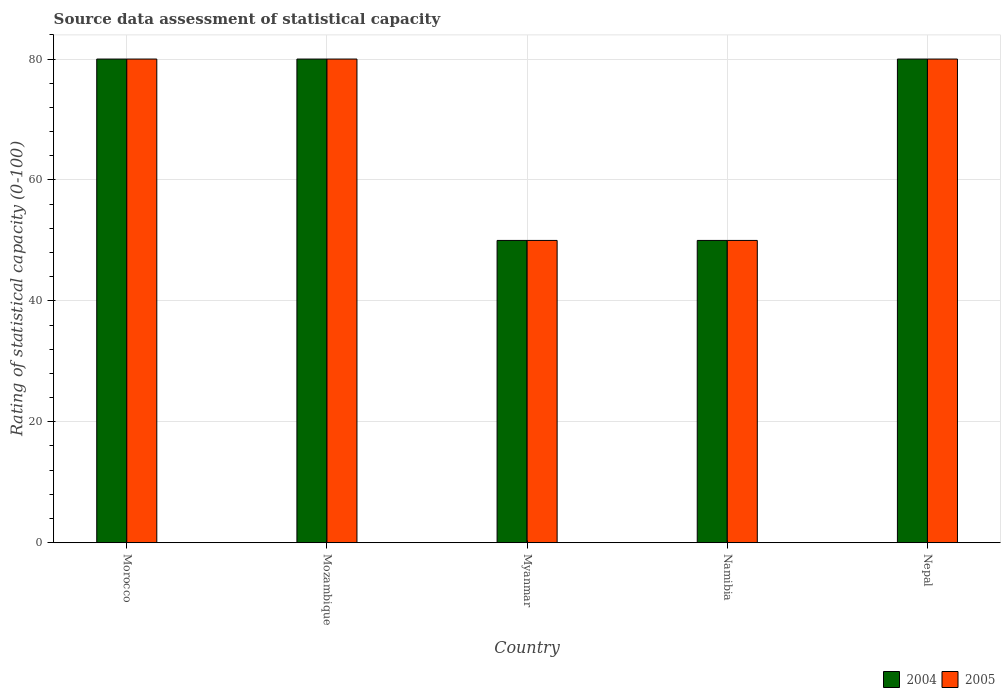How many different coloured bars are there?
Make the answer very short. 2. Are the number of bars per tick equal to the number of legend labels?
Provide a short and direct response. Yes. Are the number of bars on each tick of the X-axis equal?
Offer a terse response. Yes. How many bars are there on the 3rd tick from the left?
Ensure brevity in your answer.  2. What is the label of the 3rd group of bars from the left?
Ensure brevity in your answer.  Myanmar. What is the rating of statistical capacity in 2004 in Myanmar?
Your answer should be very brief. 50. Across all countries, what is the minimum rating of statistical capacity in 2005?
Your answer should be very brief. 50. In which country was the rating of statistical capacity in 2005 maximum?
Your response must be concise. Morocco. In which country was the rating of statistical capacity in 2004 minimum?
Your answer should be compact. Myanmar. What is the total rating of statistical capacity in 2005 in the graph?
Provide a short and direct response. 340. What is the difference between the rating of statistical capacity in 2004 in Morocco and that in Myanmar?
Provide a short and direct response. 30. What is the difference between the rating of statistical capacity in 2005 in Morocco and the rating of statistical capacity in 2004 in Nepal?
Make the answer very short. 0. What is the difference between the rating of statistical capacity of/in 2004 and rating of statistical capacity of/in 2005 in Mozambique?
Offer a very short reply. 0. Is the sum of the rating of statistical capacity in 2004 in Myanmar and Nepal greater than the maximum rating of statistical capacity in 2005 across all countries?
Provide a succinct answer. Yes. What does the 1st bar from the left in Namibia represents?
Offer a very short reply. 2004. How many countries are there in the graph?
Give a very brief answer. 5. Are the values on the major ticks of Y-axis written in scientific E-notation?
Offer a very short reply. No. Does the graph contain any zero values?
Your response must be concise. No. Does the graph contain grids?
Give a very brief answer. Yes. Where does the legend appear in the graph?
Keep it short and to the point. Bottom right. How many legend labels are there?
Provide a succinct answer. 2. How are the legend labels stacked?
Give a very brief answer. Horizontal. What is the title of the graph?
Your answer should be very brief. Source data assessment of statistical capacity. Does "1960" appear as one of the legend labels in the graph?
Make the answer very short. No. What is the label or title of the Y-axis?
Your answer should be compact. Rating of statistical capacity (0-100). What is the Rating of statistical capacity (0-100) of 2004 in Morocco?
Your answer should be compact. 80. What is the Rating of statistical capacity (0-100) in 2005 in Morocco?
Keep it short and to the point. 80. What is the Rating of statistical capacity (0-100) in 2005 in Mozambique?
Give a very brief answer. 80. What is the Rating of statistical capacity (0-100) in 2004 in Myanmar?
Offer a very short reply. 50. What is the Rating of statistical capacity (0-100) of 2005 in Myanmar?
Ensure brevity in your answer.  50. What is the Rating of statistical capacity (0-100) of 2004 in Namibia?
Provide a succinct answer. 50. What is the Rating of statistical capacity (0-100) of 2005 in Namibia?
Your answer should be very brief. 50. Across all countries, what is the maximum Rating of statistical capacity (0-100) of 2005?
Ensure brevity in your answer.  80. What is the total Rating of statistical capacity (0-100) of 2004 in the graph?
Your answer should be compact. 340. What is the total Rating of statistical capacity (0-100) in 2005 in the graph?
Provide a succinct answer. 340. What is the difference between the Rating of statistical capacity (0-100) in 2004 in Morocco and that in Mozambique?
Make the answer very short. 0. What is the difference between the Rating of statistical capacity (0-100) of 2004 in Morocco and that in Myanmar?
Offer a terse response. 30. What is the difference between the Rating of statistical capacity (0-100) in 2005 in Morocco and that in Nepal?
Your response must be concise. 0. What is the difference between the Rating of statistical capacity (0-100) of 2004 in Mozambique and that in Myanmar?
Provide a succinct answer. 30. What is the difference between the Rating of statistical capacity (0-100) in 2004 in Mozambique and that in Nepal?
Give a very brief answer. 0. What is the difference between the Rating of statistical capacity (0-100) of 2005 in Myanmar and that in Nepal?
Your answer should be compact. -30. What is the difference between the Rating of statistical capacity (0-100) in 2004 in Namibia and that in Nepal?
Provide a short and direct response. -30. What is the difference between the Rating of statistical capacity (0-100) in 2005 in Namibia and that in Nepal?
Your answer should be compact. -30. What is the difference between the Rating of statistical capacity (0-100) of 2004 in Morocco and the Rating of statistical capacity (0-100) of 2005 in Mozambique?
Offer a terse response. 0. What is the difference between the Rating of statistical capacity (0-100) in 2004 in Morocco and the Rating of statistical capacity (0-100) in 2005 in Namibia?
Provide a succinct answer. 30. What is the difference between the Rating of statistical capacity (0-100) of 2004 in Morocco and the Rating of statistical capacity (0-100) of 2005 in Nepal?
Offer a terse response. 0. What is the difference between the Rating of statistical capacity (0-100) in 2004 in Mozambique and the Rating of statistical capacity (0-100) in 2005 in Namibia?
Your answer should be compact. 30. What is the difference between the Rating of statistical capacity (0-100) in 2004 in Myanmar and the Rating of statistical capacity (0-100) in 2005 in Namibia?
Provide a succinct answer. 0. What is the average Rating of statistical capacity (0-100) of 2004 per country?
Your answer should be very brief. 68. What is the difference between the Rating of statistical capacity (0-100) in 2004 and Rating of statistical capacity (0-100) in 2005 in Morocco?
Offer a very short reply. 0. What is the difference between the Rating of statistical capacity (0-100) in 2004 and Rating of statistical capacity (0-100) in 2005 in Mozambique?
Offer a terse response. 0. What is the difference between the Rating of statistical capacity (0-100) in 2004 and Rating of statistical capacity (0-100) in 2005 in Myanmar?
Offer a very short reply. 0. What is the difference between the Rating of statistical capacity (0-100) of 2004 and Rating of statistical capacity (0-100) of 2005 in Namibia?
Provide a succinct answer. 0. What is the ratio of the Rating of statistical capacity (0-100) in 2004 in Morocco to that in Mozambique?
Provide a short and direct response. 1. What is the ratio of the Rating of statistical capacity (0-100) in 2005 in Morocco to that in Mozambique?
Your answer should be compact. 1. What is the ratio of the Rating of statistical capacity (0-100) of 2004 in Mozambique to that in Myanmar?
Keep it short and to the point. 1.6. What is the ratio of the Rating of statistical capacity (0-100) in 2004 in Mozambique to that in Namibia?
Ensure brevity in your answer.  1.6. What is the ratio of the Rating of statistical capacity (0-100) of 2005 in Mozambique to that in Namibia?
Provide a short and direct response. 1.6. What is the ratio of the Rating of statistical capacity (0-100) in 2005 in Mozambique to that in Nepal?
Offer a terse response. 1. What is the ratio of the Rating of statistical capacity (0-100) in 2005 in Myanmar to that in Nepal?
Provide a short and direct response. 0.62. What is the ratio of the Rating of statistical capacity (0-100) of 2004 in Namibia to that in Nepal?
Offer a terse response. 0.62. What is the difference between the highest and the second highest Rating of statistical capacity (0-100) of 2005?
Provide a short and direct response. 0. What is the difference between the highest and the lowest Rating of statistical capacity (0-100) in 2004?
Give a very brief answer. 30. What is the difference between the highest and the lowest Rating of statistical capacity (0-100) of 2005?
Keep it short and to the point. 30. 